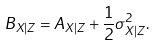Convert formula to latex. <formula><loc_0><loc_0><loc_500><loc_500>B _ { X | Z } = A _ { X | Z } + \frac { 1 } { 2 } \sigma _ { X | Z } ^ { 2 } .</formula> 